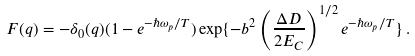<formula> <loc_0><loc_0><loc_500><loc_500>F ( q ) = - \delta _ { 0 } ( q ) ( 1 - e ^ { - \hbar { \omega } _ { p } / T } ) \exp \{ - b ^ { 2 } \left ( \frac { \Delta D } { 2 E _ { C } } \right ) ^ { 1 / 2 } e ^ { - \hbar { \omega } _ { p } / T } \} \, .</formula> 